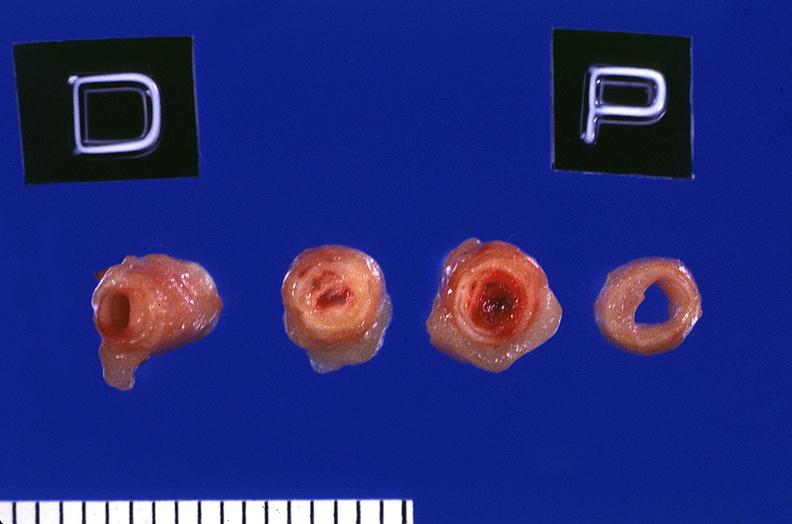s cardiovascular present?
Answer the question using a single word or phrase. Yes 